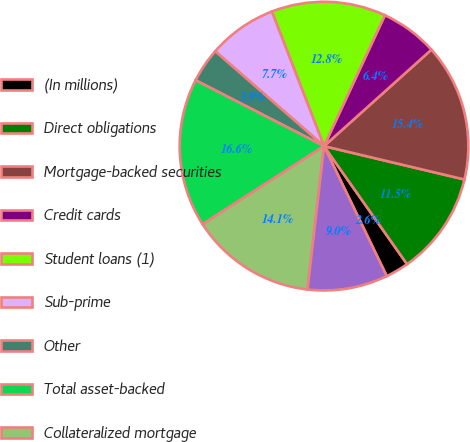Convert chart. <chart><loc_0><loc_0><loc_500><loc_500><pie_chart><fcel>(In millions)<fcel>Direct obligations<fcel>Mortgage-backed securities<fcel>Credit cards<fcel>Student loans (1)<fcel>Sub-prime<fcel>Other<fcel>Total asset-backed<fcel>Collateralized mortgage<fcel>State and political<nl><fcel>2.6%<fcel>11.53%<fcel>15.36%<fcel>6.43%<fcel>12.81%<fcel>7.7%<fcel>3.87%<fcel>16.64%<fcel>14.08%<fcel>8.98%<nl></chart> 